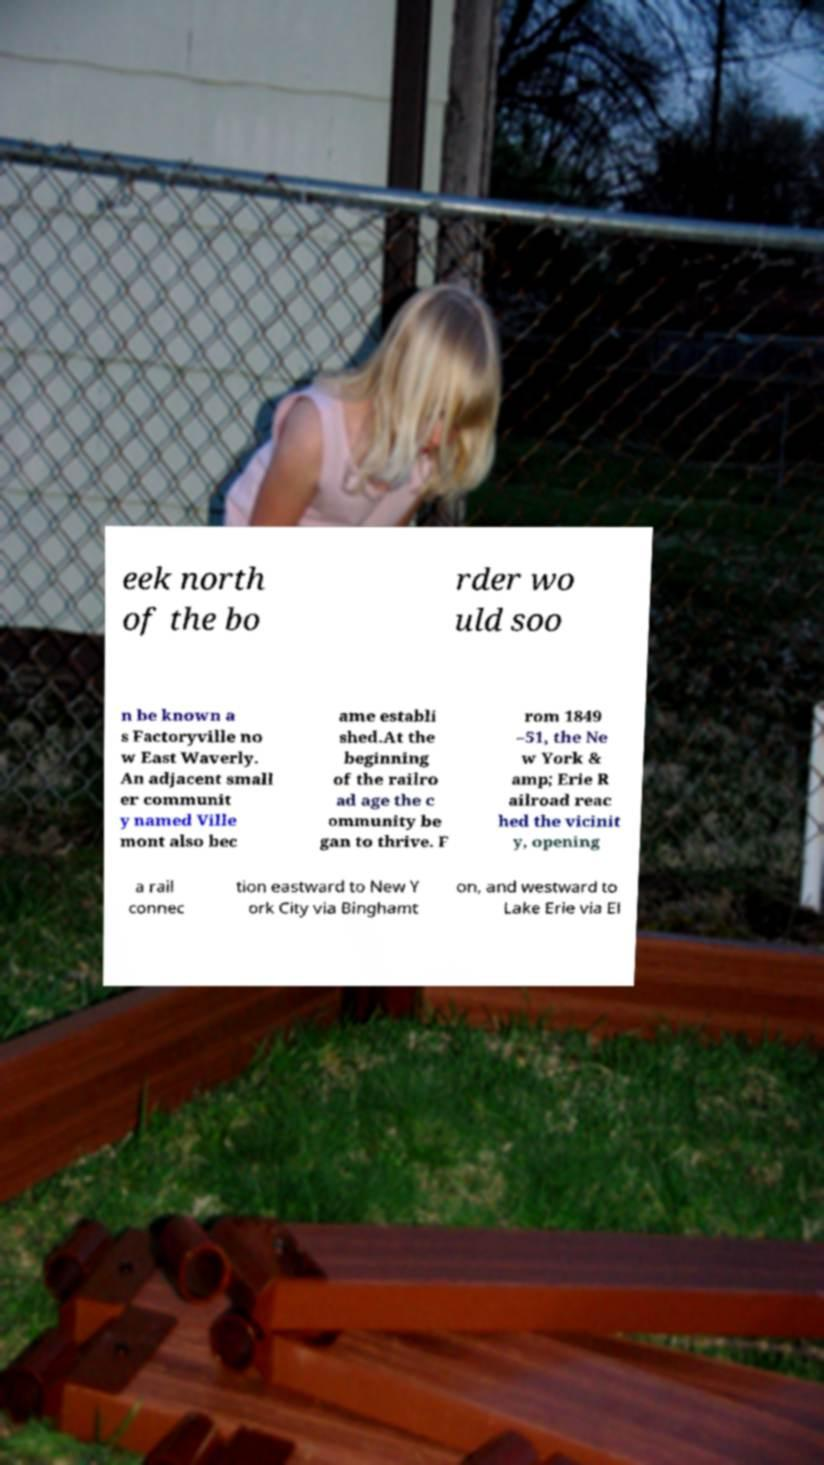Could you assist in decoding the text presented in this image and type it out clearly? eek north of the bo rder wo uld soo n be known a s Factoryville no w East Waverly. An adjacent small er communit y named Ville mont also bec ame establi shed.At the beginning of the railro ad age the c ommunity be gan to thrive. F rom 1849 –51, the Ne w York & amp; Erie R ailroad reac hed the vicinit y, opening a rail connec tion eastward to New Y ork City via Binghamt on, and westward to Lake Erie via El 